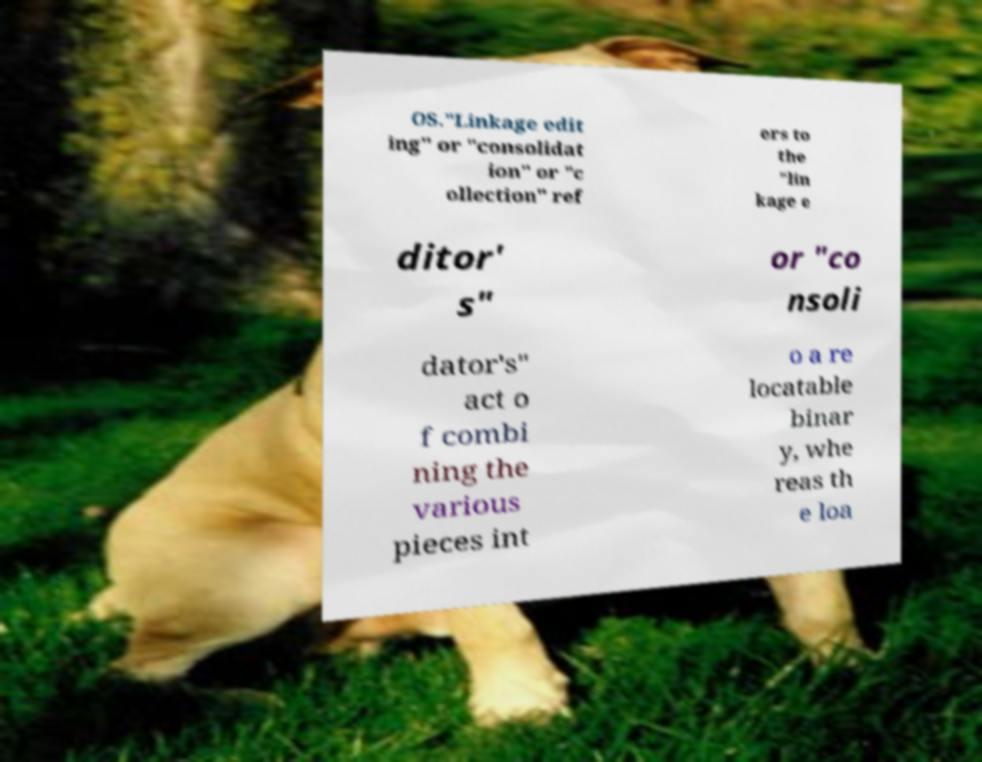Can you accurately transcribe the text from the provided image for me? OS."Linkage edit ing" or "consolidat ion" or "c ollection" ref ers to the "lin kage e ditor' s" or "co nsoli dator's" act o f combi ning the various pieces int o a re locatable binar y, whe reas th e loa 